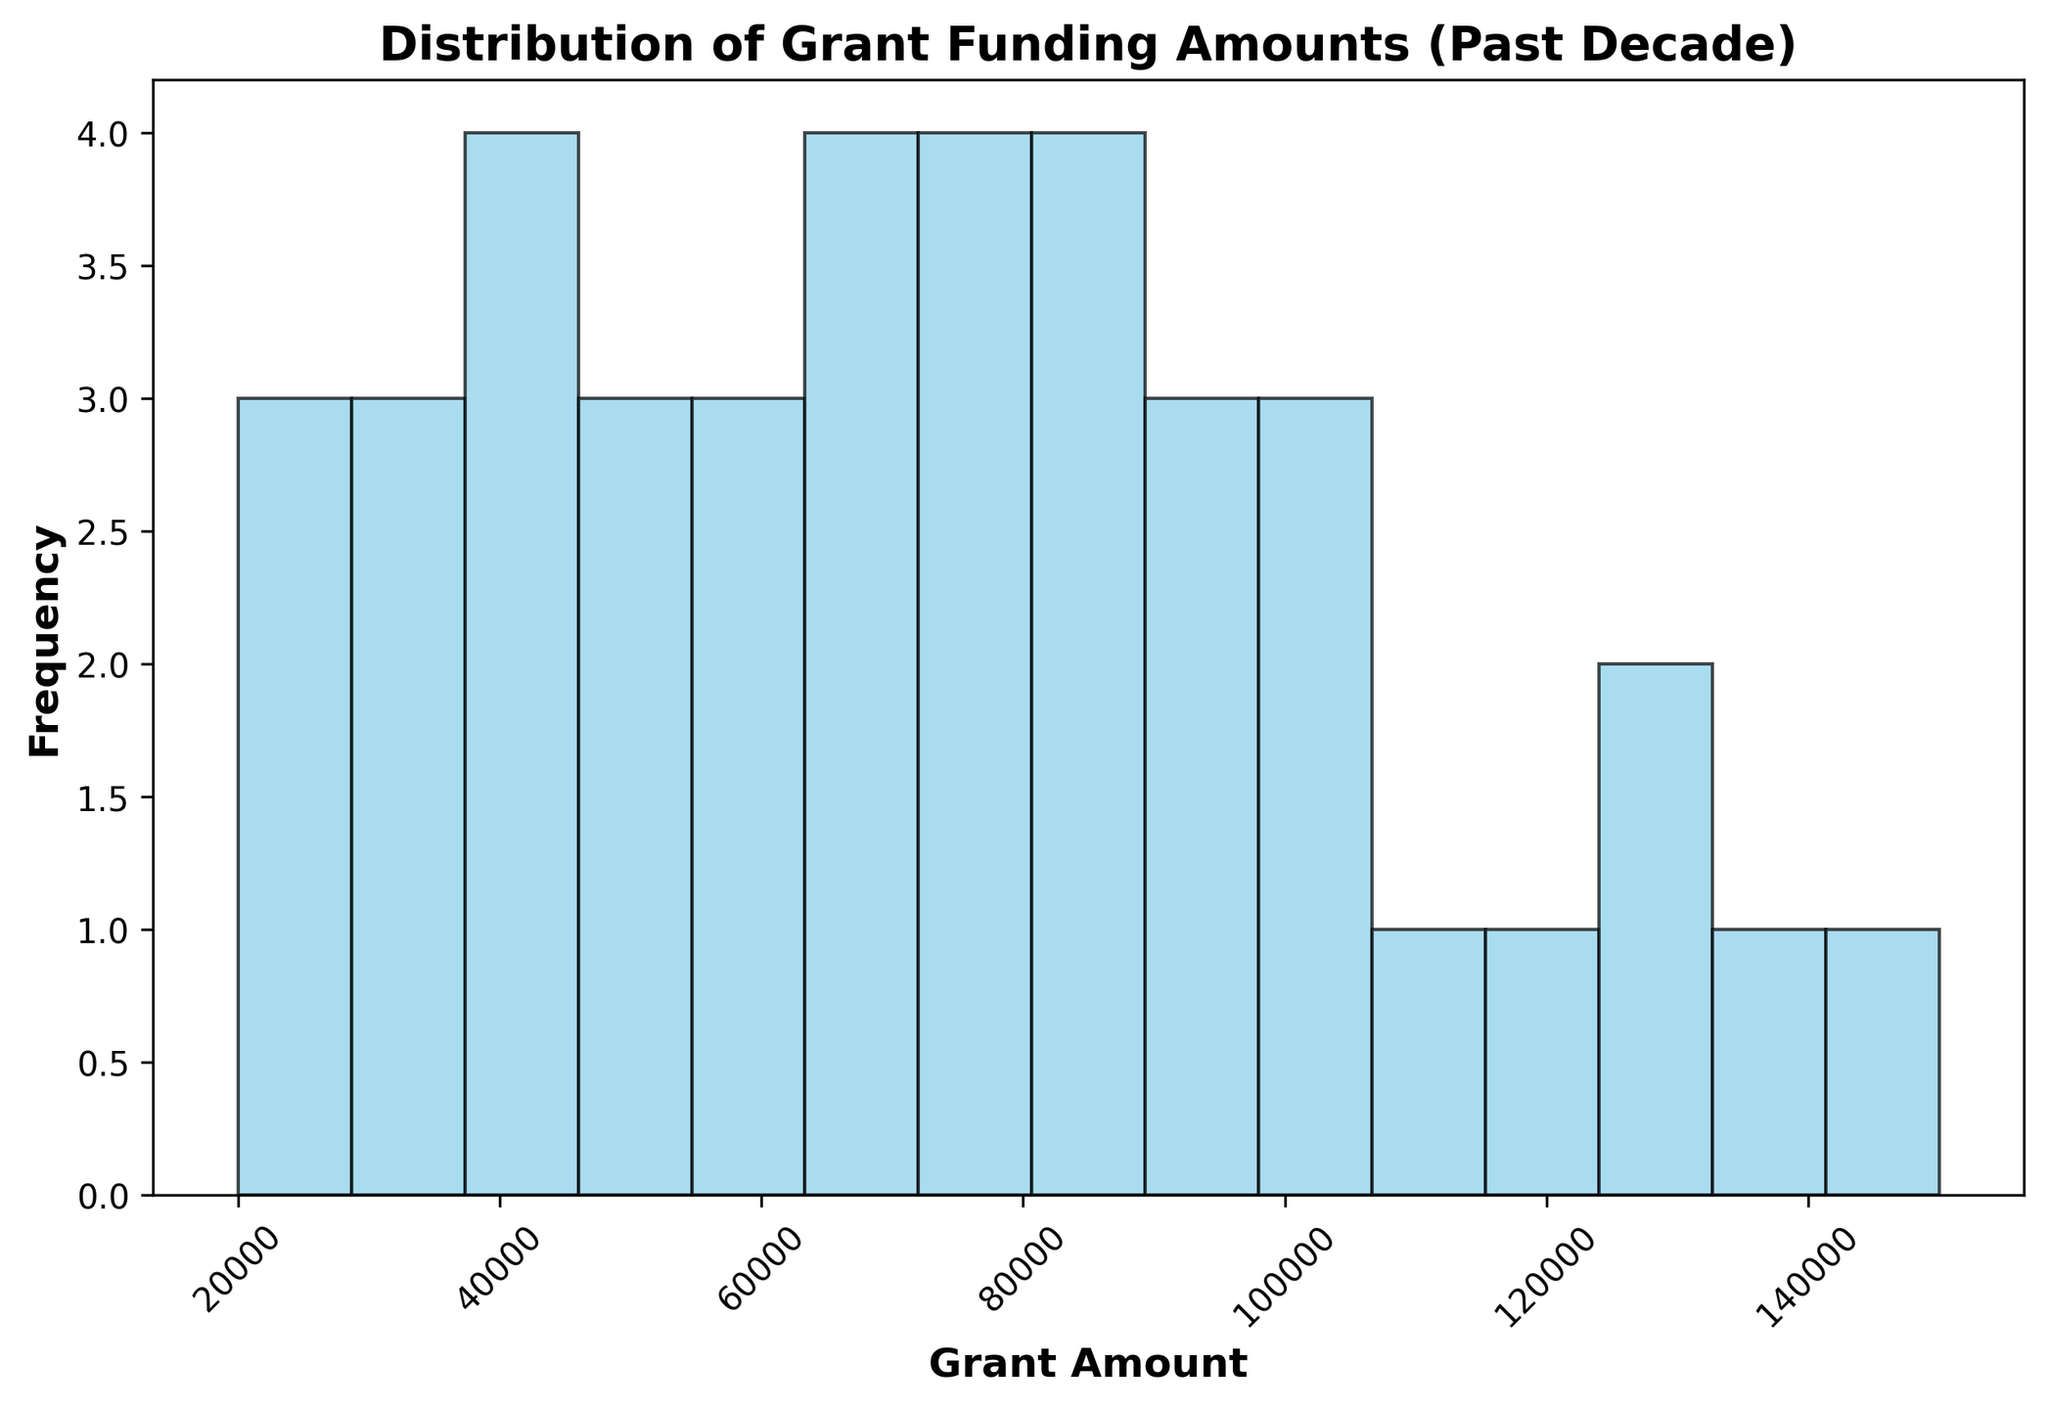What is the most frequent range of grant amounts? By observing the histogram, identify which bin (range of grant amounts) has the tallest bar, indicating the highest frequency.
Answer: $70,000 to $80,000 What is the range of grant amounts with the lowest frequency? Look for the bins with the smallest bars or no bars at all. These ranges have the lowest frequency of grant amounts.
Answer: $100,000 to $110,000 How many grant amounts are between $20,000 and $30,000? Count the height of the bar that corresponds to the $20,000 to $30,000 range.
Answer: 2 Is there a noticeable difference in frequency between lower and higher grant amounts? Compare the heights of the bins on the left side (lower grant amounts) to the bins on the right side (higher grant amounts).
Answer: Yes, lower grant amounts are less frequent What is the frequency of grant amounts between $40,000 to $50,000? Count the height of the bar that corresponds to the $40,000 to $50,000 range.
Answer: 4 How does the frequency of grant amounts between $80,000 to $90,000 compare to those between $50,000 to $60,000? Compare the heights of the bars corresponding to the $80,000 to $90,000 and $50,000 to $60,000 ranges.
Answer: $80,000 to $90,000 is more frequent Which range of grant amounts shows a higher frequency: $30,000 to $40,000 or $90,000 to $100,000? Compare the heights of the bars corresponding to the $30,000 to $40,000 and $90,000 to $100,000 ranges.
Answer: $90,000 to $100,000 What is the total frequency of grant amounts above $100,000? Add up the frequencies of all bins representing grant amounts above $100,000. Identify the height of each relevant bar and sum them up.
Answer: 6 